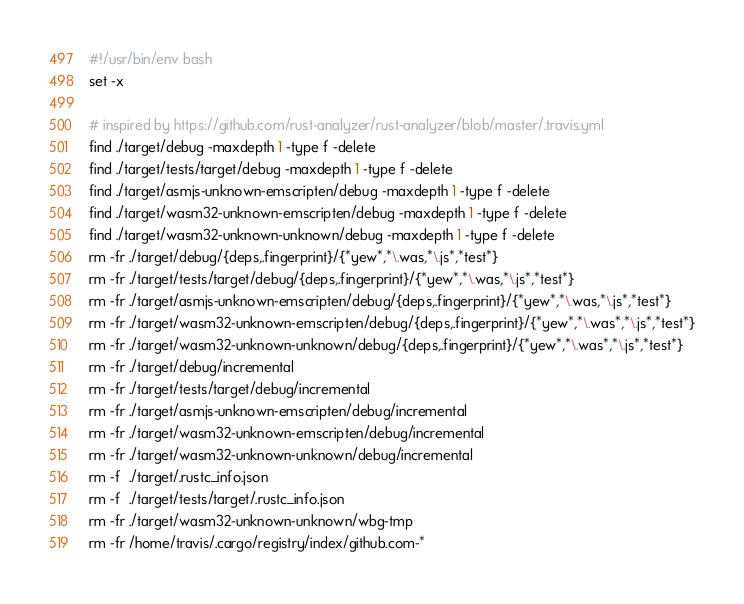<code> <loc_0><loc_0><loc_500><loc_500><_Bash_>#!/usr/bin/env bash
set -x

# inspired by https://github.com/rust-analyzer/rust-analyzer/blob/master/.travis.yml
find ./target/debug -maxdepth 1 -type f -delete
find ./target/tests/target/debug -maxdepth 1 -type f -delete
find ./target/asmjs-unknown-emscripten/debug -maxdepth 1 -type f -delete
find ./target/wasm32-unknown-emscripten/debug -maxdepth 1 -type f -delete
find ./target/wasm32-unknown-unknown/debug -maxdepth 1 -type f -delete
rm -fr ./target/debug/{deps,.fingerprint}/{*yew*,*\.was,*\.js*,*test*}
rm -fr ./target/tests/target/debug/{deps,.fingerprint}/{*yew*,*\.was,*\.js*,*test*}
rm -fr ./target/asmjs-unknown-emscripten/debug/{deps,.fingerprint}/{*yew*,*\.was,*\.js*,*test*}
rm -fr ./target/wasm32-unknown-emscripten/debug/{deps,.fingerprint}/{*yew*,*\.was*,*\.js*,*test*}
rm -fr ./target/wasm32-unknown-unknown/debug/{deps,.fingerprint}/{*yew*,*\.was*,*\.js*,*test*}
rm -fr ./target/debug/incremental
rm -fr ./target/tests/target/debug/incremental
rm -fr ./target/asmjs-unknown-emscripten/debug/incremental
rm -fr ./target/wasm32-unknown-emscripten/debug/incremental
rm -fr ./target/wasm32-unknown-unknown/debug/incremental
rm -f  ./target/.rustc_info.json
rm -f  ./target/tests/target/.rustc_info.json
rm -fr ./target/wasm32-unknown-unknown/wbg-tmp
rm -fr /home/travis/.cargo/registry/index/github.com-*</code> 